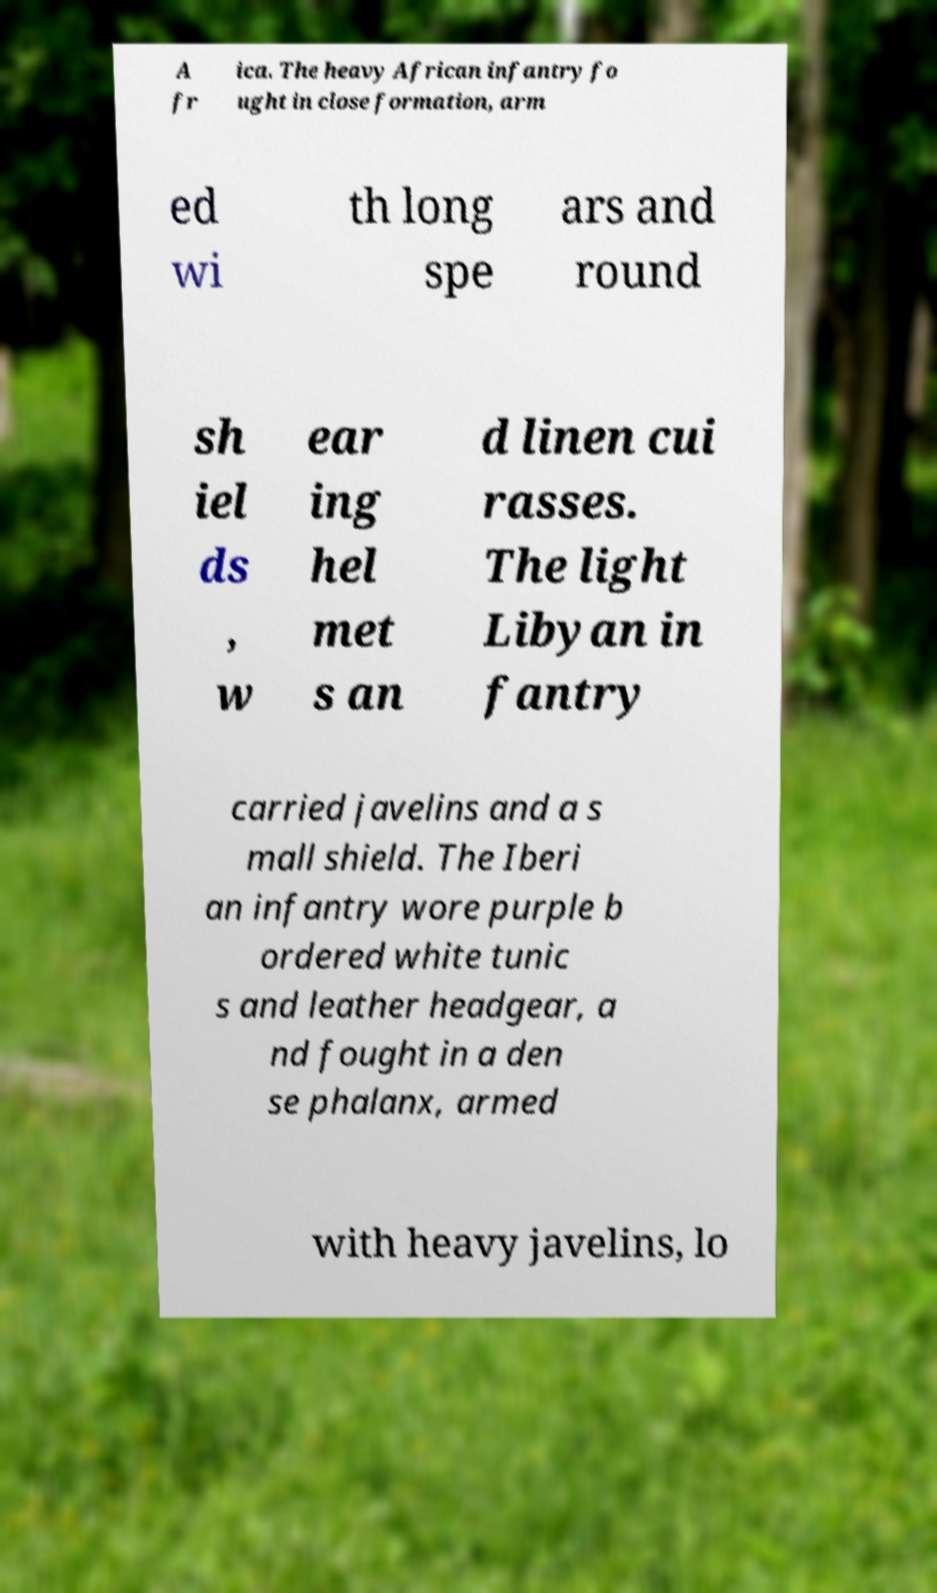What messages or text are displayed in this image? I need them in a readable, typed format. A fr ica. The heavy African infantry fo ught in close formation, arm ed wi th long spe ars and round sh iel ds , w ear ing hel met s an d linen cui rasses. The light Libyan in fantry carried javelins and a s mall shield. The Iberi an infantry wore purple b ordered white tunic s and leather headgear, a nd fought in a den se phalanx, armed with heavy javelins, lo 